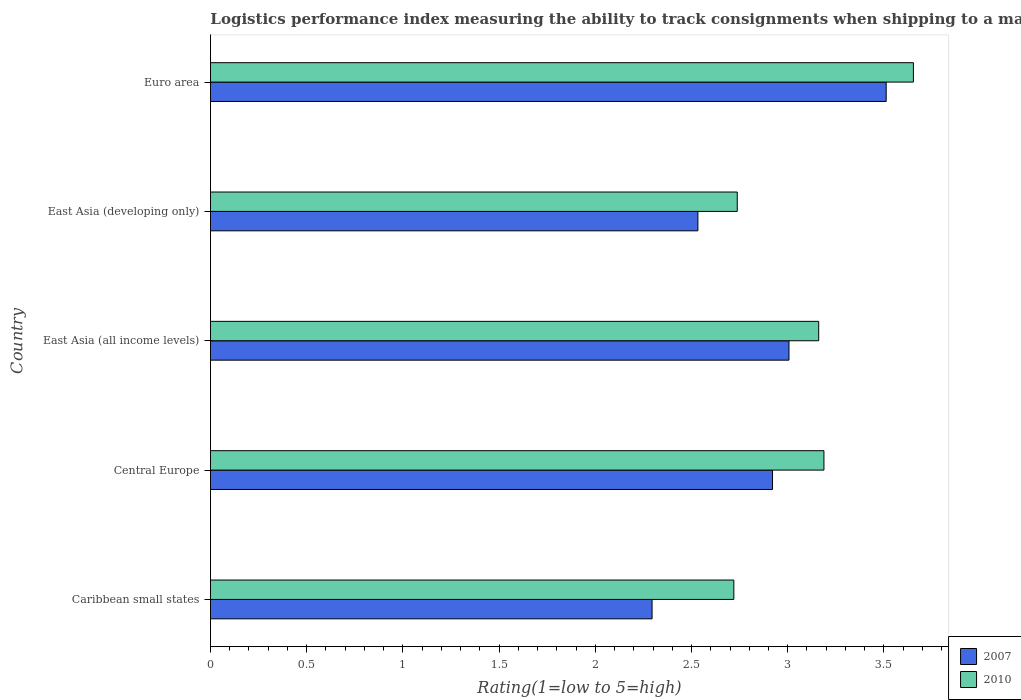How many different coloured bars are there?
Keep it short and to the point. 2. How many groups of bars are there?
Your answer should be very brief. 5. Are the number of bars per tick equal to the number of legend labels?
Give a very brief answer. Yes. Are the number of bars on each tick of the Y-axis equal?
Provide a succinct answer. Yes. What is the Logistic performance index in 2007 in Central Europe?
Provide a short and direct response. 2.92. Across all countries, what is the maximum Logistic performance index in 2007?
Provide a short and direct response. 3.51. Across all countries, what is the minimum Logistic performance index in 2010?
Provide a succinct answer. 2.72. In which country was the Logistic performance index in 2007 minimum?
Offer a very short reply. Caribbean small states. What is the total Logistic performance index in 2007 in the graph?
Your answer should be very brief. 14.27. What is the difference between the Logistic performance index in 2007 in Central Europe and that in Euro area?
Keep it short and to the point. -0.59. What is the difference between the Logistic performance index in 2007 in Euro area and the Logistic performance index in 2010 in Caribbean small states?
Ensure brevity in your answer.  0.79. What is the average Logistic performance index in 2010 per country?
Offer a terse response. 3.09. What is the difference between the Logistic performance index in 2007 and Logistic performance index in 2010 in East Asia (developing only)?
Make the answer very short. -0.2. In how many countries, is the Logistic performance index in 2010 greater than 3.2 ?
Ensure brevity in your answer.  1. What is the ratio of the Logistic performance index in 2007 in Caribbean small states to that in Euro area?
Offer a terse response. 0.65. Is the difference between the Logistic performance index in 2007 in Caribbean small states and East Asia (developing only) greater than the difference between the Logistic performance index in 2010 in Caribbean small states and East Asia (developing only)?
Your answer should be very brief. No. What is the difference between the highest and the second highest Logistic performance index in 2007?
Ensure brevity in your answer.  0.51. What is the difference between the highest and the lowest Logistic performance index in 2010?
Provide a succinct answer. 0.93. In how many countries, is the Logistic performance index in 2007 greater than the average Logistic performance index in 2007 taken over all countries?
Provide a succinct answer. 3. What does the 2nd bar from the top in Caribbean small states represents?
Offer a very short reply. 2007. What does the 1st bar from the bottom in East Asia (all income levels) represents?
Keep it short and to the point. 2007. How many bars are there?
Your answer should be compact. 10. Are all the bars in the graph horizontal?
Your answer should be compact. Yes. How many countries are there in the graph?
Offer a very short reply. 5. Are the values on the major ticks of X-axis written in scientific E-notation?
Provide a succinct answer. No. Does the graph contain any zero values?
Your answer should be very brief. No. Does the graph contain grids?
Provide a short and direct response. No. How are the legend labels stacked?
Keep it short and to the point. Vertical. What is the title of the graph?
Your answer should be very brief. Logistics performance index measuring the ability to track consignments when shipping to a market. Does "2002" appear as one of the legend labels in the graph?
Your answer should be compact. No. What is the label or title of the X-axis?
Offer a very short reply. Rating(1=low to 5=high). What is the label or title of the Y-axis?
Ensure brevity in your answer.  Country. What is the Rating(1=low to 5=high) of 2007 in Caribbean small states?
Your answer should be very brief. 2.29. What is the Rating(1=low to 5=high) in 2010 in Caribbean small states?
Offer a terse response. 2.72. What is the Rating(1=low to 5=high) of 2007 in Central Europe?
Your response must be concise. 2.92. What is the Rating(1=low to 5=high) of 2010 in Central Europe?
Your response must be concise. 3.19. What is the Rating(1=low to 5=high) in 2007 in East Asia (all income levels)?
Provide a succinct answer. 3.01. What is the Rating(1=low to 5=high) of 2010 in East Asia (all income levels)?
Your response must be concise. 3.16. What is the Rating(1=low to 5=high) in 2007 in East Asia (developing only)?
Your response must be concise. 2.53. What is the Rating(1=low to 5=high) in 2010 in East Asia (developing only)?
Offer a terse response. 2.74. What is the Rating(1=low to 5=high) in 2007 in Euro area?
Give a very brief answer. 3.51. What is the Rating(1=low to 5=high) of 2010 in Euro area?
Offer a terse response. 3.65. Across all countries, what is the maximum Rating(1=low to 5=high) of 2007?
Your answer should be very brief. 3.51. Across all countries, what is the maximum Rating(1=low to 5=high) of 2010?
Give a very brief answer. 3.65. Across all countries, what is the minimum Rating(1=low to 5=high) of 2007?
Give a very brief answer. 2.29. Across all countries, what is the minimum Rating(1=low to 5=high) in 2010?
Give a very brief answer. 2.72. What is the total Rating(1=low to 5=high) in 2007 in the graph?
Your answer should be compact. 14.27. What is the total Rating(1=low to 5=high) in 2010 in the graph?
Give a very brief answer. 15.46. What is the difference between the Rating(1=low to 5=high) in 2007 in Caribbean small states and that in Central Europe?
Offer a terse response. -0.63. What is the difference between the Rating(1=low to 5=high) in 2010 in Caribbean small states and that in Central Europe?
Your response must be concise. -0.47. What is the difference between the Rating(1=low to 5=high) of 2007 in Caribbean small states and that in East Asia (all income levels)?
Your response must be concise. -0.71. What is the difference between the Rating(1=low to 5=high) of 2010 in Caribbean small states and that in East Asia (all income levels)?
Your answer should be compact. -0.44. What is the difference between the Rating(1=low to 5=high) of 2007 in Caribbean small states and that in East Asia (developing only)?
Your response must be concise. -0.24. What is the difference between the Rating(1=low to 5=high) of 2010 in Caribbean small states and that in East Asia (developing only)?
Provide a succinct answer. -0.02. What is the difference between the Rating(1=low to 5=high) of 2007 in Caribbean small states and that in Euro area?
Keep it short and to the point. -1.22. What is the difference between the Rating(1=low to 5=high) of 2010 in Caribbean small states and that in Euro area?
Give a very brief answer. -0.93. What is the difference between the Rating(1=low to 5=high) of 2007 in Central Europe and that in East Asia (all income levels)?
Your response must be concise. -0.09. What is the difference between the Rating(1=low to 5=high) in 2010 in Central Europe and that in East Asia (all income levels)?
Your answer should be very brief. 0.03. What is the difference between the Rating(1=low to 5=high) in 2007 in Central Europe and that in East Asia (developing only)?
Provide a succinct answer. 0.39. What is the difference between the Rating(1=low to 5=high) of 2010 in Central Europe and that in East Asia (developing only)?
Make the answer very short. 0.45. What is the difference between the Rating(1=low to 5=high) in 2007 in Central Europe and that in Euro area?
Ensure brevity in your answer.  -0.59. What is the difference between the Rating(1=low to 5=high) of 2010 in Central Europe and that in Euro area?
Offer a terse response. -0.47. What is the difference between the Rating(1=low to 5=high) in 2007 in East Asia (all income levels) and that in East Asia (developing only)?
Your answer should be very brief. 0.47. What is the difference between the Rating(1=low to 5=high) in 2010 in East Asia (all income levels) and that in East Asia (developing only)?
Provide a succinct answer. 0.42. What is the difference between the Rating(1=low to 5=high) of 2007 in East Asia (all income levels) and that in Euro area?
Make the answer very short. -0.51. What is the difference between the Rating(1=low to 5=high) in 2010 in East Asia (all income levels) and that in Euro area?
Provide a succinct answer. -0.49. What is the difference between the Rating(1=low to 5=high) of 2007 in East Asia (developing only) and that in Euro area?
Your answer should be compact. -0.98. What is the difference between the Rating(1=low to 5=high) of 2010 in East Asia (developing only) and that in Euro area?
Ensure brevity in your answer.  -0.92. What is the difference between the Rating(1=low to 5=high) of 2007 in Caribbean small states and the Rating(1=low to 5=high) of 2010 in Central Europe?
Your response must be concise. -0.89. What is the difference between the Rating(1=low to 5=high) in 2007 in Caribbean small states and the Rating(1=low to 5=high) in 2010 in East Asia (all income levels)?
Your answer should be compact. -0.87. What is the difference between the Rating(1=low to 5=high) in 2007 in Caribbean small states and the Rating(1=low to 5=high) in 2010 in East Asia (developing only)?
Offer a very short reply. -0.44. What is the difference between the Rating(1=low to 5=high) in 2007 in Caribbean small states and the Rating(1=low to 5=high) in 2010 in Euro area?
Make the answer very short. -1.36. What is the difference between the Rating(1=low to 5=high) of 2007 in Central Europe and the Rating(1=low to 5=high) of 2010 in East Asia (all income levels)?
Give a very brief answer. -0.24. What is the difference between the Rating(1=low to 5=high) in 2007 in Central Europe and the Rating(1=low to 5=high) in 2010 in East Asia (developing only)?
Your answer should be compact. 0.18. What is the difference between the Rating(1=low to 5=high) in 2007 in Central Europe and the Rating(1=low to 5=high) in 2010 in Euro area?
Provide a succinct answer. -0.73. What is the difference between the Rating(1=low to 5=high) of 2007 in East Asia (all income levels) and the Rating(1=low to 5=high) of 2010 in East Asia (developing only)?
Make the answer very short. 0.27. What is the difference between the Rating(1=low to 5=high) of 2007 in East Asia (all income levels) and the Rating(1=low to 5=high) of 2010 in Euro area?
Ensure brevity in your answer.  -0.65. What is the difference between the Rating(1=low to 5=high) of 2007 in East Asia (developing only) and the Rating(1=low to 5=high) of 2010 in Euro area?
Provide a short and direct response. -1.12. What is the average Rating(1=low to 5=high) in 2007 per country?
Make the answer very short. 2.85. What is the average Rating(1=low to 5=high) of 2010 per country?
Offer a very short reply. 3.09. What is the difference between the Rating(1=low to 5=high) of 2007 and Rating(1=low to 5=high) of 2010 in Caribbean small states?
Give a very brief answer. -0.42. What is the difference between the Rating(1=low to 5=high) of 2007 and Rating(1=low to 5=high) of 2010 in Central Europe?
Provide a succinct answer. -0.27. What is the difference between the Rating(1=low to 5=high) of 2007 and Rating(1=low to 5=high) of 2010 in East Asia (all income levels)?
Provide a succinct answer. -0.15. What is the difference between the Rating(1=low to 5=high) in 2007 and Rating(1=low to 5=high) in 2010 in East Asia (developing only)?
Offer a terse response. -0.2. What is the difference between the Rating(1=low to 5=high) in 2007 and Rating(1=low to 5=high) in 2010 in Euro area?
Provide a short and direct response. -0.14. What is the ratio of the Rating(1=low to 5=high) in 2007 in Caribbean small states to that in Central Europe?
Offer a terse response. 0.79. What is the ratio of the Rating(1=low to 5=high) of 2010 in Caribbean small states to that in Central Europe?
Give a very brief answer. 0.85. What is the ratio of the Rating(1=low to 5=high) in 2007 in Caribbean small states to that in East Asia (all income levels)?
Your answer should be very brief. 0.76. What is the ratio of the Rating(1=low to 5=high) of 2010 in Caribbean small states to that in East Asia (all income levels)?
Your response must be concise. 0.86. What is the ratio of the Rating(1=low to 5=high) in 2007 in Caribbean small states to that in East Asia (developing only)?
Provide a succinct answer. 0.91. What is the ratio of the Rating(1=low to 5=high) of 2007 in Caribbean small states to that in Euro area?
Your answer should be compact. 0.65. What is the ratio of the Rating(1=low to 5=high) in 2010 in Caribbean small states to that in Euro area?
Give a very brief answer. 0.74. What is the ratio of the Rating(1=low to 5=high) in 2007 in Central Europe to that in East Asia (all income levels)?
Provide a succinct answer. 0.97. What is the ratio of the Rating(1=low to 5=high) in 2010 in Central Europe to that in East Asia (all income levels)?
Make the answer very short. 1.01. What is the ratio of the Rating(1=low to 5=high) of 2007 in Central Europe to that in East Asia (developing only)?
Give a very brief answer. 1.15. What is the ratio of the Rating(1=low to 5=high) of 2010 in Central Europe to that in East Asia (developing only)?
Your response must be concise. 1.16. What is the ratio of the Rating(1=low to 5=high) of 2007 in Central Europe to that in Euro area?
Make the answer very short. 0.83. What is the ratio of the Rating(1=low to 5=high) of 2010 in Central Europe to that in Euro area?
Ensure brevity in your answer.  0.87. What is the ratio of the Rating(1=low to 5=high) in 2007 in East Asia (all income levels) to that in East Asia (developing only)?
Your answer should be very brief. 1.19. What is the ratio of the Rating(1=low to 5=high) of 2010 in East Asia (all income levels) to that in East Asia (developing only)?
Ensure brevity in your answer.  1.15. What is the ratio of the Rating(1=low to 5=high) in 2007 in East Asia (all income levels) to that in Euro area?
Give a very brief answer. 0.86. What is the ratio of the Rating(1=low to 5=high) in 2010 in East Asia (all income levels) to that in Euro area?
Give a very brief answer. 0.87. What is the ratio of the Rating(1=low to 5=high) of 2007 in East Asia (developing only) to that in Euro area?
Ensure brevity in your answer.  0.72. What is the ratio of the Rating(1=low to 5=high) in 2010 in East Asia (developing only) to that in Euro area?
Offer a very short reply. 0.75. What is the difference between the highest and the second highest Rating(1=low to 5=high) of 2007?
Provide a short and direct response. 0.51. What is the difference between the highest and the second highest Rating(1=low to 5=high) of 2010?
Keep it short and to the point. 0.47. What is the difference between the highest and the lowest Rating(1=low to 5=high) of 2007?
Give a very brief answer. 1.22. What is the difference between the highest and the lowest Rating(1=low to 5=high) of 2010?
Provide a succinct answer. 0.93. 